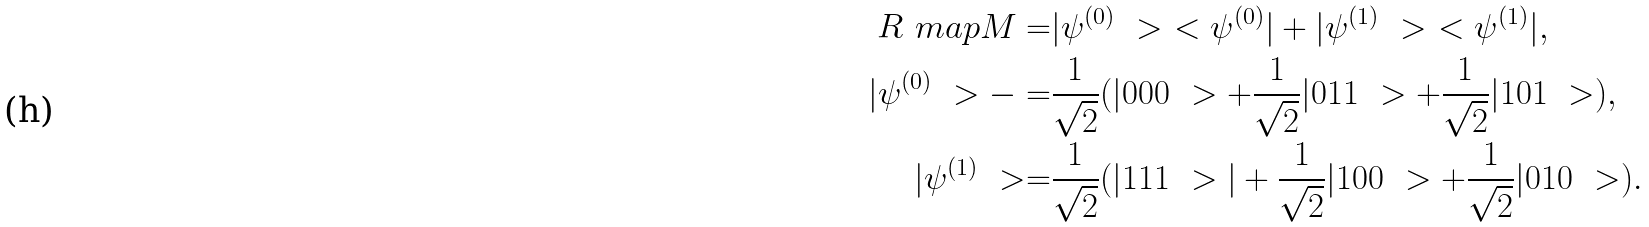Convert formula to latex. <formula><loc_0><loc_0><loc_500><loc_500>R _ { \ } m a p { M } = & | \psi ^ { ( 0 ) } \ > \ < \psi ^ { ( 0 ) } | + | \psi ^ { ( 1 ) } \ > \ < \psi ^ { ( 1 ) } | , \\ | \psi ^ { ( 0 ) } \ > - = & \frac { 1 } { \sqrt { 2 } } ( | 0 0 0 \ > + \frac { 1 } { \sqrt { 2 } } | 0 1 1 \ > + \frac { 1 } { \sqrt { 2 } } | 1 0 1 \ > ) , \\ | \psi ^ { ( 1 ) } \ > = & \frac { 1 } { \sqrt { 2 } } ( | 1 1 1 \ > | + \frac { 1 } { \sqrt { 2 } } | 1 0 0 \ > + \frac { 1 } { \sqrt { 2 } } | 0 1 0 \ > ) .</formula> 